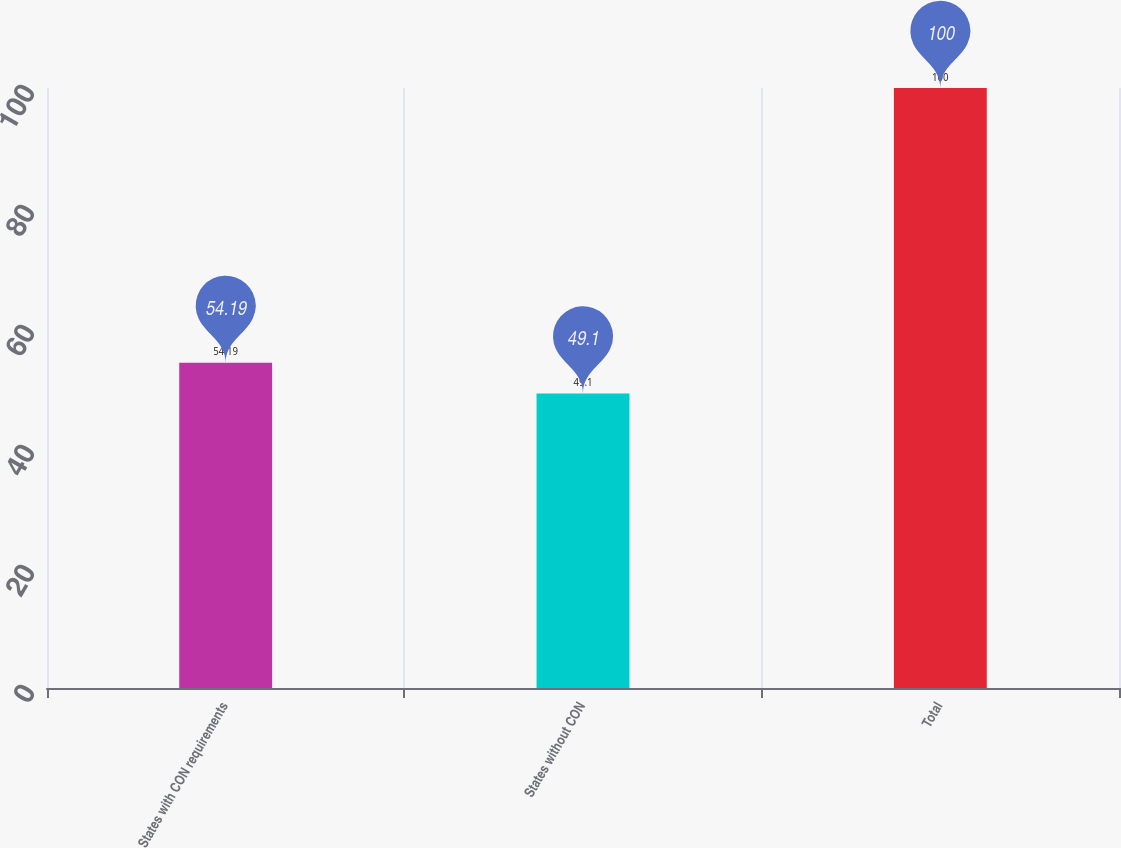Convert chart. <chart><loc_0><loc_0><loc_500><loc_500><bar_chart><fcel>States with CON requirements<fcel>States without CON<fcel>Total<nl><fcel>54.19<fcel>49.1<fcel>100<nl></chart> 